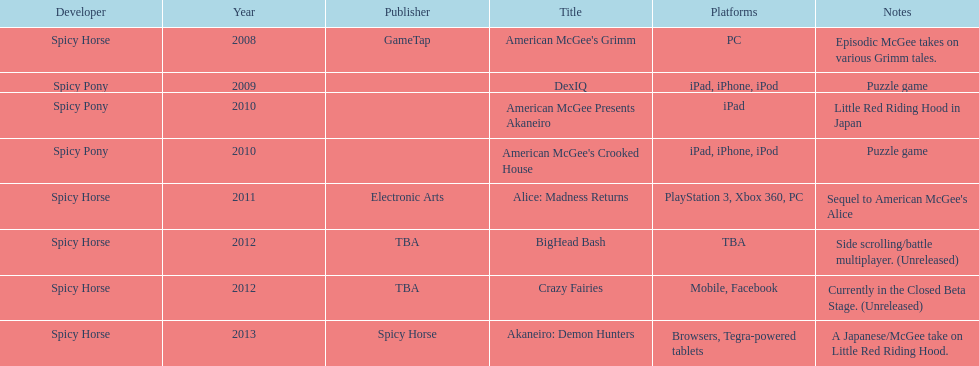Which title is for ipad but not for iphone or ipod? American McGee Presents Akaneiro. 